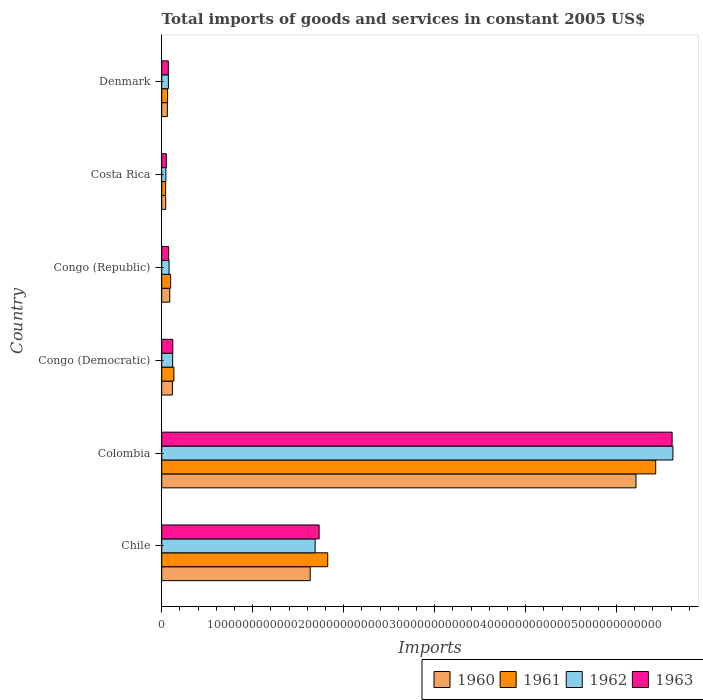Are the number of bars per tick equal to the number of legend labels?
Give a very brief answer. Yes. Are the number of bars on each tick of the Y-axis equal?
Keep it short and to the point. Yes. How many bars are there on the 2nd tick from the top?
Ensure brevity in your answer.  4. What is the label of the 4th group of bars from the top?
Ensure brevity in your answer.  Congo (Democratic). In how many cases, is the number of bars for a given country not equal to the number of legend labels?
Offer a very short reply. 0. What is the total imports of goods and services in 1963 in Congo (Democratic)?
Your answer should be compact. 1.22e+11. Across all countries, what is the maximum total imports of goods and services in 1962?
Offer a very short reply. 5.62e+12. Across all countries, what is the minimum total imports of goods and services in 1960?
Your response must be concise. 4.40e+1. In which country was the total imports of goods and services in 1962 maximum?
Provide a succinct answer. Colombia. In which country was the total imports of goods and services in 1961 minimum?
Ensure brevity in your answer.  Costa Rica. What is the total total imports of goods and services in 1960 in the graph?
Your response must be concise. 7.16e+12. What is the difference between the total imports of goods and services in 1962 in Colombia and that in Congo (Democratic)?
Your response must be concise. 5.50e+12. What is the difference between the total imports of goods and services in 1963 in Colombia and the total imports of goods and services in 1962 in Chile?
Give a very brief answer. 3.92e+12. What is the average total imports of goods and services in 1963 per country?
Keep it short and to the point. 1.28e+12. What is the difference between the total imports of goods and services in 1961 and total imports of goods and services in 1963 in Denmark?
Make the answer very short. -7.86e+09. What is the ratio of the total imports of goods and services in 1963 in Congo (Democratic) to that in Denmark?
Your response must be concise. 1.68. What is the difference between the highest and the second highest total imports of goods and services in 1960?
Your response must be concise. 3.58e+12. What is the difference between the highest and the lowest total imports of goods and services in 1961?
Your answer should be compact. 5.39e+12. What does the 4th bar from the bottom in Chile represents?
Your answer should be very brief. 1963. Is it the case that in every country, the sum of the total imports of goods and services in 1961 and total imports of goods and services in 1962 is greater than the total imports of goods and services in 1960?
Keep it short and to the point. Yes. How many bars are there?
Offer a terse response. 24. What is the difference between two consecutive major ticks on the X-axis?
Keep it short and to the point. 1.00e+12. Does the graph contain any zero values?
Provide a short and direct response. No. Does the graph contain grids?
Keep it short and to the point. No. How many legend labels are there?
Your response must be concise. 4. What is the title of the graph?
Provide a succinct answer. Total imports of goods and services in constant 2005 US$. Does "1973" appear as one of the legend labels in the graph?
Your answer should be compact. No. What is the label or title of the X-axis?
Provide a short and direct response. Imports. What is the label or title of the Y-axis?
Keep it short and to the point. Country. What is the Imports of 1960 in Chile?
Provide a succinct answer. 1.63e+12. What is the Imports of 1961 in Chile?
Provide a succinct answer. 1.82e+12. What is the Imports of 1962 in Chile?
Keep it short and to the point. 1.69e+12. What is the Imports of 1963 in Chile?
Offer a terse response. 1.73e+12. What is the Imports in 1960 in Colombia?
Your answer should be very brief. 5.21e+12. What is the Imports in 1961 in Colombia?
Provide a short and direct response. 5.43e+12. What is the Imports of 1962 in Colombia?
Ensure brevity in your answer.  5.62e+12. What is the Imports in 1963 in Colombia?
Offer a very short reply. 5.61e+12. What is the Imports of 1960 in Congo (Democratic)?
Give a very brief answer. 1.17e+11. What is the Imports in 1961 in Congo (Democratic)?
Offer a very short reply. 1.34e+11. What is the Imports in 1962 in Congo (Democratic)?
Keep it short and to the point. 1.20e+11. What is the Imports in 1963 in Congo (Democratic)?
Your answer should be compact. 1.22e+11. What is the Imports of 1960 in Congo (Republic)?
Your answer should be very brief. 8.83e+1. What is the Imports in 1961 in Congo (Republic)?
Your response must be concise. 9.83e+1. What is the Imports of 1962 in Congo (Republic)?
Ensure brevity in your answer.  8.10e+1. What is the Imports in 1963 in Congo (Republic)?
Ensure brevity in your answer.  7.65e+1. What is the Imports of 1960 in Costa Rica?
Your answer should be compact. 4.40e+1. What is the Imports in 1961 in Costa Rica?
Make the answer very short. 4.30e+1. What is the Imports of 1962 in Costa Rica?
Ensure brevity in your answer.  4.58e+1. What is the Imports in 1963 in Costa Rica?
Your answer should be very brief. 5.07e+1. What is the Imports in 1960 in Denmark?
Give a very brief answer. 6.20e+1. What is the Imports in 1961 in Denmark?
Offer a very short reply. 6.48e+1. What is the Imports of 1962 in Denmark?
Make the answer very short. 7.35e+1. What is the Imports of 1963 in Denmark?
Provide a short and direct response. 7.27e+1. Across all countries, what is the maximum Imports in 1960?
Ensure brevity in your answer.  5.21e+12. Across all countries, what is the maximum Imports in 1961?
Give a very brief answer. 5.43e+12. Across all countries, what is the maximum Imports in 1962?
Your answer should be compact. 5.62e+12. Across all countries, what is the maximum Imports of 1963?
Your answer should be compact. 5.61e+12. Across all countries, what is the minimum Imports in 1960?
Ensure brevity in your answer.  4.40e+1. Across all countries, what is the minimum Imports in 1961?
Ensure brevity in your answer.  4.30e+1. Across all countries, what is the minimum Imports of 1962?
Keep it short and to the point. 4.58e+1. Across all countries, what is the minimum Imports of 1963?
Make the answer very short. 5.07e+1. What is the total Imports in 1960 in the graph?
Offer a terse response. 7.16e+12. What is the total Imports of 1961 in the graph?
Provide a succinct answer. 7.60e+12. What is the total Imports in 1962 in the graph?
Make the answer very short. 7.63e+12. What is the total Imports of 1963 in the graph?
Keep it short and to the point. 7.66e+12. What is the difference between the Imports of 1960 in Chile and that in Colombia?
Make the answer very short. -3.58e+12. What is the difference between the Imports of 1961 in Chile and that in Colombia?
Make the answer very short. -3.61e+12. What is the difference between the Imports of 1962 in Chile and that in Colombia?
Ensure brevity in your answer.  -3.93e+12. What is the difference between the Imports in 1963 in Chile and that in Colombia?
Ensure brevity in your answer.  -3.88e+12. What is the difference between the Imports of 1960 in Chile and that in Congo (Democratic)?
Ensure brevity in your answer.  1.51e+12. What is the difference between the Imports in 1961 in Chile and that in Congo (Democratic)?
Ensure brevity in your answer.  1.69e+12. What is the difference between the Imports of 1962 in Chile and that in Congo (Democratic)?
Give a very brief answer. 1.57e+12. What is the difference between the Imports of 1963 in Chile and that in Congo (Democratic)?
Keep it short and to the point. 1.61e+12. What is the difference between the Imports in 1960 in Chile and that in Congo (Republic)?
Offer a terse response. 1.54e+12. What is the difference between the Imports of 1961 in Chile and that in Congo (Republic)?
Ensure brevity in your answer.  1.73e+12. What is the difference between the Imports of 1962 in Chile and that in Congo (Republic)?
Make the answer very short. 1.61e+12. What is the difference between the Imports of 1963 in Chile and that in Congo (Republic)?
Ensure brevity in your answer.  1.65e+12. What is the difference between the Imports in 1960 in Chile and that in Costa Rica?
Provide a short and direct response. 1.59e+12. What is the difference between the Imports in 1961 in Chile and that in Costa Rica?
Offer a terse response. 1.78e+12. What is the difference between the Imports of 1962 in Chile and that in Costa Rica?
Ensure brevity in your answer.  1.64e+12. What is the difference between the Imports of 1963 in Chile and that in Costa Rica?
Offer a very short reply. 1.68e+12. What is the difference between the Imports of 1960 in Chile and that in Denmark?
Make the answer very short. 1.57e+12. What is the difference between the Imports of 1961 in Chile and that in Denmark?
Make the answer very short. 1.76e+12. What is the difference between the Imports in 1962 in Chile and that in Denmark?
Your response must be concise. 1.61e+12. What is the difference between the Imports in 1963 in Chile and that in Denmark?
Your answer should be compact. 1.66e+12. What is the difference between the Imports in 1960 in Colombia and that in Congo (Democratic)?
Offer a very short reply. 5.10e+12. What is the difference between the Imports of 1961 in Colombia and that in Congo (Democratic)?
Your response must be concise. 5.30e+12. What is the difference between the Imports in 1962 in Colombia and that in Congo (Democratic)?
Your answer should be compact. 5.50e+12. What is the difference between the Imports of 1963 in Colombia and that in Congo (Democratic)?
Your answer should be compact. 5.49e+12. What is the difference between the Imports in 1960 in Colombia and that in Congo (Republic)?
Your response must be concise. 5.13e+12. What is the difference between the Imports of 1961 in Colombia and that in Congo (Republic)?
Give a very brief answer. 5.33e+12. What is the difference between the Imports in 1962 in Colombia and that in Congo (Republic)?
Offer a terse response. 5.54e+12. What is the difference between the Imports of 1963 in Colombia and that in Congo (Republic)?
Your response must be concise. 5.53e+12. What is the difference between the Imports in 1960 in Colombia and that in Costa Rica?
Ensure brevity in your answer.  5.17e+12. What is the difference between the Imports of 1961 in Colombia and that in Costa Rica?
Give a very brief answer. 5.39e+12. What is the difference between the Imports of 1962 in Colombia and that in Costa Rica?
Your answer should be compact. 5.57e+12. What is the difference between the Imports of 1963 in Colombia and that in Costa Rica?
Your answer should be compact. 5.56e+12. What is the difference between the Imports in 1960 in Colombia and that in Denmark?
Provide a short and direct response. 5.15e+12. What is the difference between the Imports of 1961 in Colombia and that in Denmark?
Your answer should be compact. 5.37e+12. What is the difference between the Imports of 1962 in Colombia and that in Denmark?
Give a very brief answer. 5.55e+12. What is the difference between the Imports in 1963 in Colombia and that in Denmark?
Provide a short and direct response. 5.54e+12. What is the difference between the Imports in 1960 in Congo (Democratic) and that in Congo (Republic)?
Offer a terse response. 2.90e+1. What is the difference between the Imports in 1961 in Congo (Democratic) and that in Congo (Republic)?
Offer a very short reply. 3.59e+1. What is the difference between the Imports of 1962 in Congo (Democratic) and that in Congo (Republic)?
Your answer should be very brief. 3.95e+1. What is the difference between the Imports in 1963 in Congo (Democratic) and that in Congo (Republic)?
Offer a terse response. 4.53e+1. What is the difference between the Imports of 1960 in Congo (Democratic) and that in Costa Rica?
Your answer should be compact. 7.34e+1. What is the difference between the Imports of 1961 in Congo (Democratic) and that in Costa Rica?
Your answer should be very brief. 9.11e+1. What is the difference between the Imports of 1962 in Congo (Democratic) and that in Costa Rica?
Provide a short and direct response. 7.47e+1. What is the difference between the Imports in 1963 in Congo (Democratic) and that in Costa Rica?
Give a very brief answer. 7.11e+1. What is the difference between the Imports in 1960 in Congo (Democratic) and that in Denmark?
Offer a terse response. 5.53e+1. What is the difference between the Imports in 1961 in Congo (Democratic) and that in Denmark?
Offer a very short reply. 6.94e+1. What is the difference between the Imports in 1962 in Congo (Democratic) and that in Denmark?
Ensure brevity in your answer.  4.70e+1. What is the difference between the Imports of 1963 in Congo (Democratic) and that in Denmark?
Make the answer very short. 4.91e+1. What is the difference between the Imports of 1960 in Congo (Republic) and that in Costa Rica?
Keep it short and to the point. 4.43e+1. What is the difference between the Imports in 1961 in Congo (Republic) and that in Costa Rica?
Keep it short and to the point. 5.52e+1. What is the difference between the Imports in 1962 in Congo (Republic) and that in Costa Rica?
Ensure brevity in your answer.  3.52e+1. What is the difference between the Imports in 1963 in Congo (Republic) and that in Costa Rica?
Ensure brevity in your answer.  2.58e+1. What is the difference between the Imports of 1960 in Congo (Republic) and that in Denmark?
Give a very brief answer. 2.63e+1. What is the difference between the Imports of 1961 in Congo (Republic) and that in Denmark?
Ensure brevity in your answer.  3.35e+1. What is the difference between the Imports of 1962 in Congo (Republic) and that in Denmark?
Keep it short and to the point. 7.52e+09. What is the difference between the Imports in 1963 in Congo (Republic) and that in Denmark?
Keep it short and to the point. 3.84e+09. What is the difference between the Imports in 1960 in Costa Rica and that in Denmark?
Offer a very short reply. -1.80e+1. What is the difference between the Imports of 1961 in Costa Rica and that in Denmark?
Ensure brevity in your answer.  -2.18e+1. What is the difference between the Imports of 1962 in Costa Rica and that in Denmark?
Offer a terse response. -2.77e+1. What is the difference between the Imports in 1963 in Costa Rica and that in Denmark?
Give a very brief answer. -2.19e+1. What is the difference between the Imports in 1960 in Chile and the Imports in 1961 in Colombia?
Your answer should be very brief. -3.80e+12. What is the difference between the Imports of 1960 in Chile and the Imports of 1962 in Colombia?
Make the answer very short. -3.99e+12. What is the difference between the Imports in 1960 in Chile and the Imports in 1963 in Colombia?
Make the answer very short. -3.98e+12. What is the difference between the Imports of 1961 in Chile and the Imports of 1962 in Colombia?
Offer a very short reply. -3.79e+12. What is the difference between the Imports in 1961 in Chile and the Imports in 1963 in Colombia?
Offer a terse response. -3.79e+12. What is the difference between the Imports in 1962 in Chile and the Imports in 1963 in Colombia?
Your response must be concise. -3.92e+12. What is the difference between the Imports in 1960 in Chile and the Imports in 1961 in Congo (Democratic)?
Make the answer very short. 1.50e+12. What is the difference between the Imports in 1960 in Chile and the Imports in 1962 in Congo (Democratic)?
Make the answer very short. 1.51e+12. What is the difference between the Imports in 1960 in Chile and the Imports in 1963 in Congo (Democratic)?
Give a very brief answer. 1.51e+12. What is the difference between the Imports of 1961 in Chile and the Imports of 1962 in Congo (Democratic)?
Offer a terse response. 1.70e+12. What is the difference between the Imports in 1961 in Chile and the Imports in 1963 in Congo (Democratic)?
Give a very brief answer. 1.70e+12. What is the difference between the Imports of 1962 in Chile and the Imports of 1963 in Congo (Democratic)?
Give a very brief answer. 1.56e+12. What is the difference between the Imports of 1960 in Chile and the Imports of 1961 in Congo (Republic)?
Provide a succinct answer. 1.53e+12. What is the difference between the Imports of 1960 in Chile and the Imports of 1962 in Congo (Republic)?
Make the answer very short. 1.55e+12. What is the difference between the Imports of 1960 in Chile and the Imports of 1963 in Congo (Republic)?
Ensure brevity in your answer.  1.56e+12. What is the difference between the Imports of 1961 in Chile and the Imports of 1962 in Congo (Republic)?
Give a very brief answer. 1.74e+12. What is the difference between the Imports in 1961 in Chile and the Imports in 1963 in Congo (Republic)?
Give a very brief answer. 1.75e+12. What is the difference between the Imports of 1962 in Chile and the Imports of 1963 in Congo (Republic)?
Your answer should be very brief. 1.61e+12. What is the difference between the Imports of 1960 in Chile and the Imports of 1961 in Costa Rica?
Your answer should be very brief. 1.59e+12. What is the difference between the Imports in 1960 in Chile and the Imports in 1962 in Costa Rica?
Provide a succinct answer. 1.59e+12. What is the difference between the Imports of 1960 in Chile and the Imports of 1963 in Costa Rica?
Provide a short and direct response. 1.58e+12. What is the difference between the Imports in 1961 in Chile and the Imports in 1962 in Costa Rica?
Offer a terse response. 1.78e+12. What is the difference between the Imports in 1961 in Chile and the Imports in 1963 in Costa Rica?
Keep it short and to the point. 1.77e+12. What is the difference between the Imports in 1962 in Chile and the Imports in 1963 in Costa Rica?
Keep it short and to the point. 1.64e+12. What is the difference between the Imports of 1960 in Chile and the Imports of 1961 in Denmark?
Give a very brief answer. 1.57e+12. What is the difference between the Imports in 1960 in Chile and the Imports in 1962 in Denmark?
Provide a succinct answer. 1.56e+12. What is the difference between the Imports in 1960 in Chile and the Imports in 1963 in Denmark?
Keep it short and to the point. 1.56e+12. What is the difference between the Imports in 1961 in Chile and the Imports in 1962 in Denmark?
Offer a very short reply. 1.75e+12. What is the difference between the Imports of 1961 in Chile and the Imports of 1963 in Denmark?
Offer a very short reply. 1.75e+12. What is the difference between the Imports in 1962 in Chile and the Imports in 1963 in Denmark?
Give a very brief answer. 1.61e+12. What is the difference between the Imports of 1960 in Colombia and the Imports of 1961 in Congo (Democratic)?
Your answer should be compact. 5.08e+12. What is the difference between the Imports in 1960 in Colombia and the Imports in 1962 in Congo (Democratic)?
Give a very brief answer. 5.09e+12. What is the difference between the Imports of 1960 in Colombia and the Imports of 1963 in Congo (Democratic)?
Offer a terse response. 5.09e+12. What is the difference between the Imports in 1961 in Colombia and the Imports in 1962 in Congo (Democratic)?
Offer a very short reply. 5.31e+12. What is the difference between the Imports of 1961 in Colombia and the Imports of 1963 in Congo (Democratic)?
Your answer should be very brief. 5.31e+12. What is the difference between the Imports of 1962 in Colombia and the Imports of 1963 in Congo (Democratic)?
Give a very brief answer. 5.50e+12. What is the difference between the Imports in 1960 in Colombia and the Imports in 1961 in Congo (Republic)?
Offer a very short reply. 5.12e+12. What is the difference between the Imports in 1960 in Colombia and the Imports in 1962 in Congo (Republic)?
Ensure brevity in your answer.  5.13e+12. What is the difference between the Imports in 1960 in Colombia and the Imports in 1963 in Congo (Republic)?
Your answer should be very brief. 5.14e+12. What is the difference between the Imports in 1961 in Colombia and the Imports in 1962 in Congo (Republic)?
Offer a terse response. 5.35e+12. What is the difference between the Imports in 1961 in Colombia and the Imports in 1963 in Congo (Republic)?
Provide a succinct answer. 5.35e+12. What is the difference between the Imports of 1962 in Colombia and the Imports of 1963 in Congo (Republic)?
Make the answer very short. 5.54e+12. What is the difference between the Imports in 1960 in Colombia and the Imports in 1961 in Costa Rica?
Your answer should be compact. 5.17e+12. What is the difference between the Imports in 1960 in Colombia and the Imports in 1962 in Costa Rica?
Ensure brevity in your answer.  5.17e+12. What is the difference between the Imports of 1960 in Colombia and the Imports of 1963 in Costa Rica?
Your answer should be compact. 5.16e+12. What is the difference between the Imports of 1961 in Colombia and the Imports of 1962 in Costa Rica?
Provide a short and direct response. 5.38e+12. What is the difference between the Imports in 1961 in Colombia and the Imports in 1963 in Costa Rica?
Give a very brief answer. 5.38e+12. What is the difference between the Imports of 1962 in Colombia and the Imports of 1963 in Costa Rica?
Your answer should be very brief. 5.57e+12. What is the difference between the Imports of 1960 in Colombia and the Imports of 1961 in Denmark?
Offer a terse response. 5.15e+12. What is the difference between the Imports in 1960 in Colombia and the Imports in 1962 in Denmark?
Your answer should be compact. 5.14e+12. What is the difference between the Imports of 1960 in Colombia and the Imports of 1963 in Denmark?
Your answer should be compact. 5.14e+12. What is the difference between the Imports of 1961 in Colombia and the Imports of 1962 in Denmark?
Your answer should be compact. 5.36e+12. What is the difference between the Imports in 1961 in Colombia and the Imports in 1963 in Denmark?
Offer a very short reply. 5.36e+12. What is the difference between the Imports in 1962 in Colombia and the Imports in 1963 in Denmark?
Make the answer very short. 5.55e+12. What is the difference between the Imports of 1960 in Congo (Democratic) and the Imports of 1961 in Congo (Republic)?
Provide a succinct answer. 1.91e+1. What is the difference between the Imports of 1960 in Congo (Democratic) and the Imports of 1962 in Congo (Republic)?
Offer a terse response. 3.64e+1. What is the difference between the Imports of 1960 in Congo (Democratic) and the Imports of 1963 in Congo (Republic)?
Offer a terse response. 4.09e+1. What is the difference between the Imports in 1961 in Congo (Democratic) and the Imports in 1962 in Congo (Republic)?
Ensure brevity in your answer.  5.32e+1. What is the difference between the Imports in 1961 in Congo (Democratic) and the Imports in 1963 in Congo (Republic)?
Your answer should be very brief. 5.77e+1. What is the difference between the Imports in 1962 in Congo (Democratic) and the Imports in 1963 in Congo (Republic)?
Your response must be concise. 4.40e+1. What is the difference between the Imports of 1960 in Congo (Democratic) and the Imports of 1961 in Costa Rica?
Keep it short and to the point. 7.43e+1. What is the difference between the Imports in 1960 in Congo (Democratic) and the Imports in 1962 in Costa Rica?
Your answer should be very brief. 7.16e+1. What is the difference between the Imports of 1960 in Congo (Democratic) and the Imports of 1963 in Costa Rica?
Keep it short and to the point. 6.66e+1. What is the difference between the Imports of 1961 in Congo (Democratic) and the Imports of 1962 in Costa Rica?
Make the answer very short. 8.84e+1. What is the difference between the Imports of 1961 in Congo (Democratic) and the Imports of 1963 in Costa Rica?
Provide a succinct answer. 8.34e+1. What is the difference between the Imports of 1962 in Congo (Democratic) and the Imports of 1963 in Costa Rica?
Provide a succinct answer. 6.98e+1. What is the difference between the Imports in 1960 in Congo (Democratic) and the Imports in 1961 in Denmark?
Offer a very short reply. 5.26e+1. What is the difference between the Imports of 1960 in Congo (Democratic) and the Imports of 1962 in Denmark?
Give a very brief answer. 4.39e+1. What is the difference between the Imports in 1960 in Congo (Democratic) and the Imports in 1963 in Denmark?
Offer a terse response. 4.47e+1. What is the difference between the Imports in 1961 in Congo (Democratic) and the Imports in 1962 in Denmark?
Your answer should be compact. 6.07e+1. What is the difference between the Imports in 1961 in Congo (Democratic) and the Imports in 1963 in Denmark?
Your answer should be compact. 6.15e+1. What is the difference between the Imports of 1962 in Congo (Democratic) and the Imports of 1963 in Denmark?
Provide a short and direct response. 4.78e+1. What is the difference between the Imports of 1960 in Congo (Republic) and the Imports of 1961 in Costa Rica?
Ensure brevity in your answer.  4.53e+1. What is the difference between the Imports in 1960 in Congo (Republic) and the Imports in 1962 in Costa Rica?
Offer a terse response. 4.26e+1. What is the difference between the Imports of 1960 in Congo (Republic) and the Imports of 1963 in Costa Rica?
Offer a very short reply. 3.76e+1. What is the difference between the Imports of 1961 in Congo (Republic) and the Imports of 1962 in Costa Rica?
Your answer should be compact. 5.25e+1. What is the difference between the Imports of 1961 in Congo (Republic) and the Imports of 1963 in Costa Rica?
Keep it short and to the point. 4.76e+1. What is the difference between the Imports in 1962 in Congo (Republic) and the Imports in 1963 in Costa Rica?
Provide a succinct answer. 3.03e+1. What is the difference between the Imports in 1960 in Congo (Republic) and the Imports in 1961 in Denmark?
Offer a very short reply. 2.35e+1. What is the difference between the Imports in 1960 in Congo (Republic) and the Imports in 1962 in Denmark?
Provide a succinct answer. 1.49e+1. What is the difference between the Imports in 1960 in Congo (Republic) and the Imports in 1963 in Denmark?
Make the answer very short. 1.57e+1. What is the difference between the Imports of 1961 in Congo (Republic) and the Imports of 1962 in Denmark?
Provide a short and direct response. 2.48e+1. What is the difference between the Imports in 1961 in Congo (Republic) and the Imports in 1963 in Denmark?
Provide a succinct answer. 2.56e+1. What is the difference between the Imports of 1962 in Congo (Republic) and the Imports of 1963 in Denmark?
Make the answer very short. 8.32e+09. What is the difference between the Imports in 1960 in Costa Rica and the Imports in 1961 in Denmark?
Keep it short and to the point. -2.08e+1. What is the difference between the Imports in 1960 in Costa Rica and the Imports in 1962 in Denmark?
Provide a succinct answer. -2.95e+1. What is the difference between the Imports in 1960 in Costa Rica and the Imports in 1963 in Denmark?
Offer a terse response. -2.87e+1. What is the difference between the Imports in 1961 in Costa Rica and the Imports in 1962 in Denmark?
Keep it short and to the point. -3.04e+1. What is the difference between the Imports of 1961 in Costa Rica and the Imports of 1963 in Denmark?
Your answer should be compact. -2.96e+1. What is the difference between the Imports of 1962 in Costa Rica and the Imports of 1963 in Denmark?
Your answer should be compact. -2.69e+1. What is the average Imports in 1960 per country?
Ensure brevity in your answer.  1.19e+12. What is the average Imports of 1961 per country?
Ensure brevity in your answer.  1.27e+12. What is the average Imports of 1962 per country?
Ensure brevity in your answer.  1.27e+12. What is the average Imports of 1963 per country?
Your answer should be compact. 1.28e+12. What is the difference between the Imports of 1960 and Imports of 1961 in Chile?
Provide a succinct answer. -1.93e+11. What is the difference between the Imports of 1960 and Imports of 1962 in Chile?
Your answer should be very brief. -5.42e+1. What is the difference between the Imports in 1960 and Imports in 1963 in Chile?
Provide a short and direct response. -9.81e+1. What is the difference between the Imports of 1961 and Imports of 1962 in Chile?
Make the answer very short. 1.39e+11. What is the difference between the Imports of 1961 and Imports of 1963 in Chile?
Offer a terse response. 9.46e+1. What is the difference between the Imports of 1962 and Imports of 1963 in Chile?
Make the answer very short. -4.39e+1. What is the difference between the Imports of 1960 and Imports of 1961 in Colombia?
Give a very brief answer. -2.17e+11. What is the difference between the Imports in 1960 and Imports in 1962 in Colombia?
Provide a short and direct response. -4.06e+11. What is the difference between the Imports in 1960 and Imports in 1963 in Colombia?
Provide a succinct answer. -3.97e+11. What is the difference between the Imports in 1961 and Imports in 1962 in Colombia?
Your answer should be compact. -1.89e+11. What is the difference between the Imports in 1961 and Imports in 1963 in Colombia?
Your response must be concise. -1.80e+11. What is the difference between the Imports in 1962 and Imports in 1963 in Colombia?
Provide a succinct answer. 9.11e+09. What is the difference between the Imports in 1960 and Imports in 1961 in Congo (Democratic)?
Ensure brevity in your answer.  -1.68e+1. What is the difference between the Imports of 1960 and Imports of 1962 in Congo (Democratic)?
Your response must be concise. -3.13e+09. What is the difference between the Imports in 1960 and Imports in 1963 in Congo (Democratic)?
Offer a terse response. -4.41e+09. What is the difference between the Imports in 1961 and Imports in 1962 in Congo (Democratic)?
Keep it short and to the point. 1.37e+1. What is the difference between the Imports of 1961 and Imports of 1963 in Congo (Democratic)?
Make the answer very short. 1.24e+1. What is the difference between the Imports of 1962 and Imports of 1963 in Congo (Democratic)?
Provide a short and direct response. -1.28e+09. What is the difference between the Imports of 1960 and Imports of 1961 in Congo (Republic)?
Offer a terse response. -9.92e+09. What is the difference between the Imports of 1960 and Imports of 1962 in Congo (Republic)?
Offer a terse response. 7.36e+09. What is the difference between the Imports in 1960 and Imports in 1963 in Congo (Republic)?
Ensure brevity in your answer.  1.18e+1. What is the difference between the Imports of 1961 and Imports of 1962 in Congo (Republic)?
Make the answer very short. 1.73e+1. What is the difference between the Imports of 1961 and Imports of 1963 in Congo (Republic)?
Your response must be concise. 2.18e+1. What is the difference between the Imports in 1962 and Imports in 1963 in Congo (Republic)?
Make the answer very short. 4.48e+09. What is the difference between the Imports in 1960 and Imports in 1961 in Costa Rica?
Your answer should be very brief. 9.75e+08. What is the difference between the Imports in 1960 and Imports in 1962 in Costa Rica?
Offer a very short reply. -1.77e+09. What is the difference between the Imports of 1960 and Imports of 1963 in Costa Rica?
Keep it short and to the point. -6.71e+09. What is the difference between the Imports of 1961 and Imports of 1962 in Costa Rica?
Keep it short and to the point. -2.75e+09. What is the difference between the Imports in 1961 and Imports in 1963 in Costa Rica?
Provide a short and direct response. -7.69e+09. What is the difference between the Imports in 1962 and Imports in 1963 in Costa Rica?
Provide a short and direct response. -4.94e+09. What is the difference between the Imports in 1960 and Imports in 1961 in Denmark?
Your answer should be compact. -2.76e+09. What is the difference between the Imports of 1960 and Imports of 1962 in Denmark?
Offer a very short reply. -1.14e+1. What is the difference between the Imports of 1960 and Imports of 1963 in Denmark?
Keep it short and to the point. -1.06e+1. What is the difference between the Imports of 1961 and Imports of 1962 in Denmark?
Your response must be concise. -8.66e+09. What is the difference between the Imports of 1961 and Imports of 1963 in Denmark?
Give a very brief answer. -7.86e+09. What is the difference between the Imports in 1962 and Imports in 1963 in Denmark?
Your response must be concise. 8.02e+08. What is the ratio of the Imports in 1960 in Chile to that in Colombia?
Keep it short and to the point. 0.31. What is the ratio of the Imports of 1961 in Chile to that in Colombia?
Your answer should be very brief. 0.34. What is the ratio of the Imports in 1962 in Chile to that in Colombia?
Ensure brevity in your answer.  0.3. What is the ratio of the Imports in 1963 in Chile to that in Colombia?
Ensure brevity in your answer.  0.31. What is the ratio of the Imports of 1960 in Chile to that in Congo (Democratic)?
Your response must be concise. 13.91. What is the ratio of the Imports of 1961 in Chile to that in Congo (Democratic)?
Keep it short and to the point. 13.6. What is the ratio of the Imports in 1962 in Chile to that in Congo (Democratic)?
Ensure brevity in your answer.  14. What is the ratio of the Imports in 1963 in Chile to that in Congo (Democratic)?
Your response must be concise. 14.21. What is the ratio of the Imports of 1960 in Chile to that in Congo (Republic)?
Offer a terse response. 18.47. What is the ratio of the Imports in 1961 in Chile to that in Congo (Republic)?
Provide a succinct answer. 18.57. What is the ratio of the Imports of 1962 in Chile to that in Congo (Republic)?
Your answer should be compact. 20.82. What is the ratio of the Imports of 1963 in Chile to that in Congo (Republic)?
Offer a terse response. 22.62. What is the ratio of the Imports in 1960 in Chile to that in Costa Rica?
Your answer should be very brief. 37.09. What is the ratio of the Imports of 1961 in Chile to that in Costa Rica?
Give a very brief answer. 42.41. What is the ratio of the Imports in 1962 in Chile to that in Costa Rica?
Offer a terse response. 36.84. What is the ratio of the Imports in 1963 in Chile to that in Costa Rica?
Keep it short and to the point. 34.12. What is the ratio of the Imports in 1960 in Chile to that in Denmark?
Your answer should be very brief. 26.31. What is the ratio of the Imports of 1961 in Chile to that in Denmark?
Your answer should be very brief. 28.16. What is the ratio of the Imports in 1962 in Chile to that in Denmark?
Provide a succinct answer. 22.96. What is the ratio of the Imports in 1963 in Chile to that in Denmark?
Give a very brief answer. 23.81. What is the ratio of the Imports in 1960 in Colombia to that in Congo (Democratic)?
Ensure brevity in your answer.  44.42. What is the ratio of the Imports in 1961 in Colombia to that in Congo (Democratic)?
Offer a very short reply. 40.47. What is the ratio of the Imports in 1962 in Colombia to that in Congo (Democratic)?
Make the answer very short. 46.63. What is the ratio of the Imports of 1963 in Colombia to that in Congo (Democratic)?
Provide a short and direct response. 46.07. What is the ratio of the Imports in 1960 in Colombia to that in Congo (Republic)?
Ensure brevity in your answer.  59.01. What is the ratio of the Imports of 1961 in Colombia to that in Congo (Republic)?
Make the answer very short. 55.26. What is the ratio of the Imports of 1962 in Colombia to that in Congo (Republic)?
Make the answer very short. 69.39. What is the ratio of the Imports in 1963 in Colombia to that in Congo (Republic)?
Keep it short and to the point. 73.33. What is the ratio of the Imports of 1960 in Colombia to that in Costa Rica?
Your response must be concise. 118.47. What is the ratio of the Imports in 1961 in Colombia to that in Costa Rica?
Offer a very short reply. 126.19. What is the ratio of the Imports in 1962 in Colombia to that in Costa Rica?
Your answer should be compact. 122.75. What is the ratio of the Imports in 1963 in Colombia to that in Costa Rica?
Your answer should be compact. 110.62. What is the ratio of the Imports in 1960 in Colombia to that in Denmark?
Offer a very short reply. 84.03. What is the ratio of the Imports in 1961 in Colombia to that in Denmark?
Ensure brevity in your answer.  83.8. What is the ratio of the Imports of 1962 in Colombia to that in Denmark?
Your answer should be compact. 76.49. What is the ratio of the Imports in 1963 in Colombia to that in Denmark?
Ensure brevity in your answer.  77.21. What is the ratio of the Imports in 1960 in Congo (Democratic) to that in Congo (Republic)?
Keep it short and to the point. 1.33. What is the ratio of the Imports in 1961 in Congo (Democratic) to that in Congo (Republic)?
Your response must be concise. 1.37. What is the ratio of the Imports in 1962 in Congo (Democratic) to that in Congo (Republic)?
Keep it short and to the point. 1.49. What is the ratio of the Imports in 1963 in Congo (Democratic) to that in Congo (Republic)?
Your response must be concise. 1.59. What is the ratio of the Imports of 1960 in Congo (Democratic) to that in Costa Rica?
Keep it short and to the point. 2.67. What is the ratio of the Imports of 1961 in Congo (Democratic) to that in Costa Rica?
Provide a succinct answer. 3.12. What is the ratio of the Imports in 1962 in Congo (Democratic) to that in Costa Rica?
Provide a succinct answer. 2.63. What is the ratio of the Imports in 1963 in Congo (Democratic) to that in Costa Rica?
Provide a succinct answer. 2.4. What is the ratio of the Imports of 1960 in Congo (Democratic) to that in Denmark?
Your response must be concise. 1.89. What is the ratio of the Imports of 1961 in Congo (Democratic) to that in Denmark?
Your response must be concise. 2.07. What is the ratio of the Imports of 1962 in Congo (Democratic) to that in Denmark?
Your answer should be very brief. 1.64. What is the ratio of the Imports of 1963 in Congo (Democratic) to that in Denmark?
Keep it short and to the point. 1.68. What is the ratio of the Imports of 1960 in Congo (Republic) to that in Costa Rica?
Your answer should be compact. 2.01. What is the ratio of the Imports of 1961 in Congo (Republic) to that in Costa Rica?
Provide a succinct answer. 2.28. What is the ratio of the Imports in 1962 in Congo (Republic) to that in Costa Rica?
Your answer should be compact. 1.77. What is the ratio of the Imports in 1963 in Congo (Republic) to that in Costa Rica?
Your answer should be very brief. 1.51. What is the ratio of the Imports in 1960 in Congo (Republic) to that in Denmark?
Provide a succinct answer. 1.42. What is the ratio of the Imports of 1961 in Congo (Republic) to that in Denmark?
Offer a very short reply. 1.52. What is the ratio of the Imports in 1962 in Congo (Republic) to that in Denmark?
Your answer should be compact. 1.1. What is the ratio of the Imports in 1963 in Congo (Republic) to that in Denmark?
Give a very brief answer. 1.05. What is the ratio of the Imports in 1960 in Costa Rica to that in Denmark?
Your answer should be very brief. 0.71. What is the ratio of the Imports of 1961 in Costa Rica to that in Denmark?
Your response must be concise. 0.66. What is the ratio of the Imports in 1962 in Costa Rica to that in Denmark?
Offer a very short reply. 0.62. What is the ratio of the Imports of 1963 in Costa Rica to that in Denmark?
Your answer should be very brief. 0.7. What is the difference between the highest and the second highest Imports in 1960?
Offer a terse response. 3.58e+12. What is the difference between the highest and the second highest Imports of 1961?
Offer a terse response. 3.61e+12. What is the difference between the highest and the second highest Imports in 1962?
Keep it short and to the point. 3.93e+12. What is the difference between the highest and the second highest Imports in 1963?
Provide a succinct answer. 3.88e+12. What is the difference between the highest and the lowest Imports of 1960?
Your answer should be compact. 5.17e+12. What is the difference between the highest and the lowest Imports of 1961?
Your answer should be compact. 5.39e+12. What is the difference between the highest and the lowest Imports of 1962?
Your response must be concise. 5.57e+12. What is the difference between the highest and the lowest Imports in 1963?
Keep it short and to the point. 5.56e+12. 